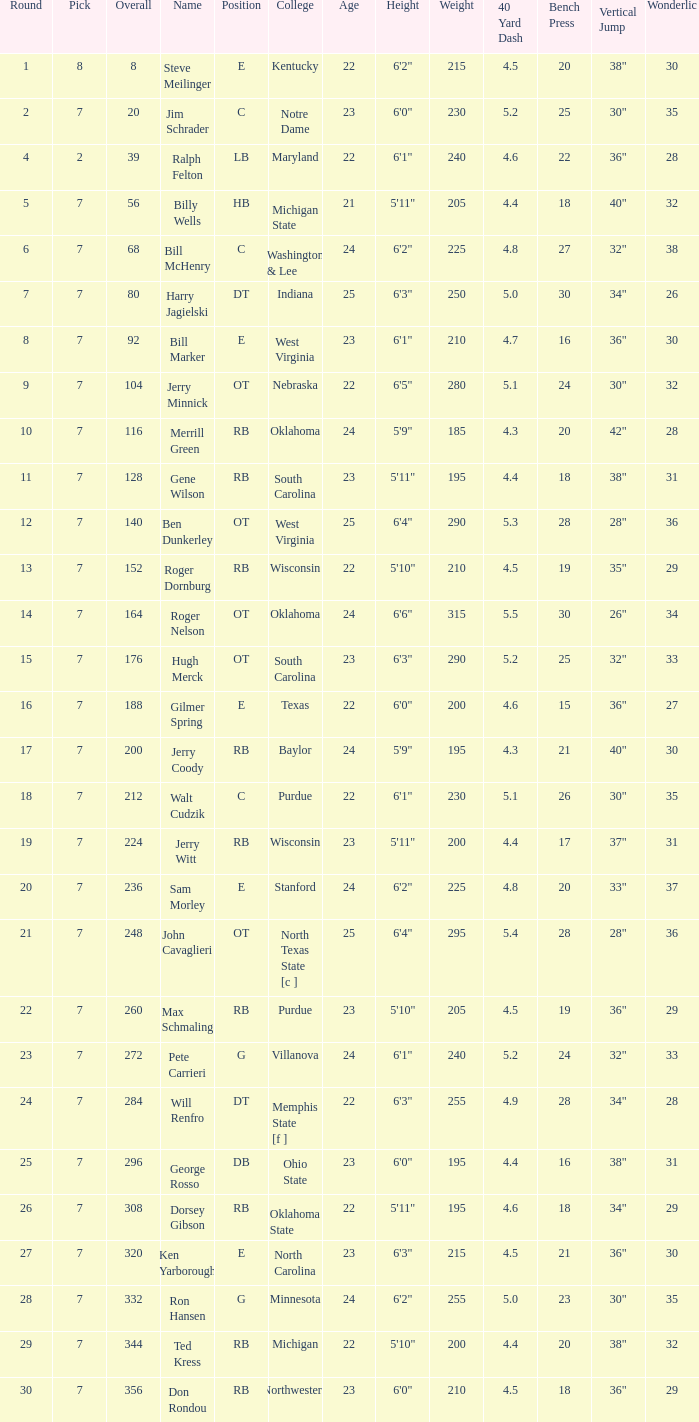Give me the full table as a dictionary. {'header': ['Round', 'Pick', 'Overall', 'Name', 'Position', 'College', 'Age', 'Height', 'Weight', '40 Yard Dash', 'Bench Press', 'Vertical Jump', 'Wonderlic'], 'rows': [['1', '8', '8', 'Steve Meilinger', 'E', 'Kentucky', '22', '6\'2"', '215', '4.5', '20', '38"', '30'], ['2', '7', '20', 'Jim Schrader', 'C', 'Notre Dame', '23', '6\'0"', '230', '5.2', '25', '30"', '35'], ['4', '2', '39', 'Ralph Felton', 'LB', 'Maryland', '22', '6\'1"', '240', '4.6', '22', '36"', '28'], ['5', '7', '56', 'Billy Wells', 'HB', 'Michigan State', '21', '5\'11"', '205', '4.4', '18', '40"', '32'], ['6', '7', '68', 'Bill McHenry', 'C', 'Washington & Lee', '24', '6\'2"', '225', '4.8', '27', '32"', '38'], ['7', '7', '80', 'Harry Jagielski', 'DT', 'Indiana', '25', '6\'3"', '250', '5.0', '30', '34"', '26'], ['8', '7', '92', 'Bill Marker', 'E', 'West Virginia', '23', '6\'1"', '210', '4.7', '16', '36"', '30'], ['9', '7', '104', 'Jerry Minnick', 'OT', 'Nebraska', '22', '6\'5"', '280', '5.1', '24', '30"', '32'], ['10', '7', '116', 'Merrill Green', 'RB', 'Oklahoma', '24', '5\'9"', '185', '4.3', '20', '42"', '28'], ['11', '7', '128', 'Gene Wilson', 'RB', 'South Carolina', '23', '5\'11"', '195', '4.4', '18', '38"', '31'], ['12', '7', '140', 'Ben Dunkerley', 'OT', 'West Virginia', '25', '6\'4"', '290', '5.3', '28', '28"', '36'], ['13', '7', '152', 'Roger Dornburg', 'RB', 'Wisconsin', '22', '5\'10"', '210', '4.5', '19', '35"', '29'], ['14', '7', '164', 'Roger Nelson', 'OT', 'Oklahoma', '24', '6\'6"', '315', '5.5', '30', '26"', '34'], ['15', '7', '176', 'Hugh Merck', 'OT', 'South Carolina', '23', '6\'3"', '290', '5.2', '25', '32"', '33'], ['16', '7', '188', 'Gilmer Spring', 'E', 'Texas', '22', '6\'0"', '200', '4.6', '15', '36"', '27'], ['17', '7', '200', 'Jerry Coody', 'RB', 'Baylor', '24', '5\'9"', '195', '4.3', '21', '40"', '30'], ['18', '7', '212', 'Walt Cudzik', 'C', 'Purdue', '22', '6\'1"', '230', '5.1', '26', '30"', '35'], ['19', '7', '224', 'Jerry Witt', 'RB', 'Wisconsin', '23', '5\'11"', '200', '4.4', '17', '37"', '31'], ['20', '7', '236', 'Sam Morley', 'E', 'Stanford', '24', '6\'2"', '225', '4.8', '20', '33"', '37'], ['21', '7', '248', 'John Cavaglieri', 'OT', 'North Texas State [c ]', '25', '6\'4"', '295', '5.4', '28', '28"', '36'], ['22', '7', '260', 'Max Schmaling', 'RB', 'Purdue', '23', '5\'10"', '205', '4.5', '19', '36"', '29'], ['23', '7', '272', 'Pete Carrieri', 'G', 'Villanova', '24', '6\'1"', '240', '5.2', '24', '32"', '33'], ['24', '7', '284', 'Will Renfro', 'DT', 'Memphis State [f ]', '22', '6\'3"', '255', '4.9', '28', '34"', '28'], ['25', '7', '296', 'George Rosso', 'DB', 'Ohio State', '23', '6\'0"', '195', '4.4', '16', '38"', '31'], ['26', '7', '308', 'Dorsey Gibson', 'RB', 'Oklahoma State', '22', '5\'11"', '195', '4.6', '18', '34"', '29'], ['27', '7', '320', 'Ken Yarborough', 'E', 'North Carolina', '23', '6\'3"', '215', '4.5', '21', '36"', '30'], ['28', '7', '332', 'Ron Hansen', 'G', 'Minnesota', '24', '6\'2"', '255', '5.0', '23', '30"', '35'], ['29', '7', '344', 'Ted Kress', 'RB', 'Michigan', '22', '5\'10"', '200', '4.4', '20', '38"', '32'], ['30', '7', '356', 'Don Rondou', 'RB', 'Northwestern', '23', '6\'0"', '210', '4.5', '18', '36"', '29']]} What is the number of the round in which Ron Hansen was drafted and the overall is greater than 332? 0.0. 